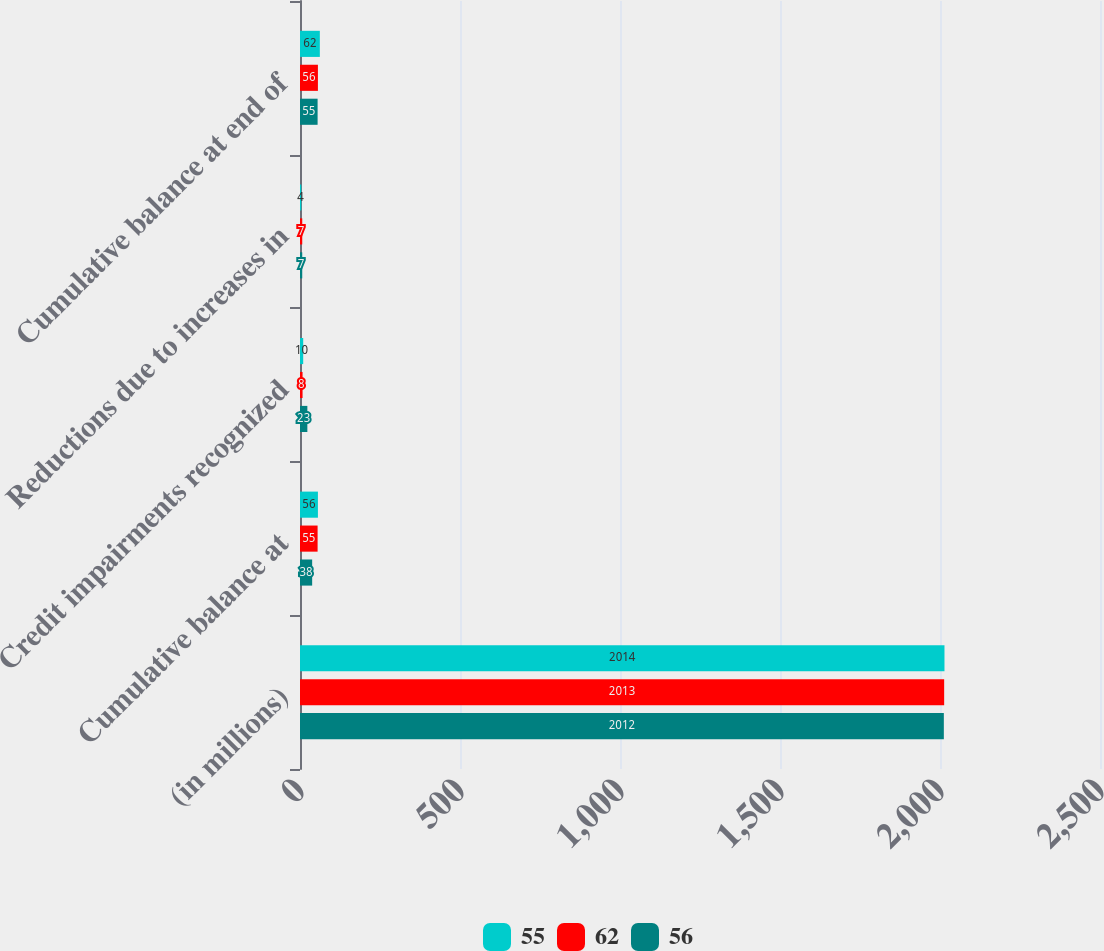<chart> <loc_0><loc_0><loc_500><loc_500><stacked_bar_chart><ecel><fcel>(in millions)<fcel>Cumulative balance at<fcel>Credit impairments recognized<fcel>Reductions due to increases in<fcel>Cumulative balance at end of<nl><fcel>55<fcel>2014<fcel>56<fcel>10<fcel>4<fcel>62<nl><fcel>62<fcel>2013<fcel>55<fcel>8<fcel>7<fcel>56<nl><fcel>56<fcel>2012<fcel>38<fcel>23<fcel>7<fcel>55<nl></chart> 